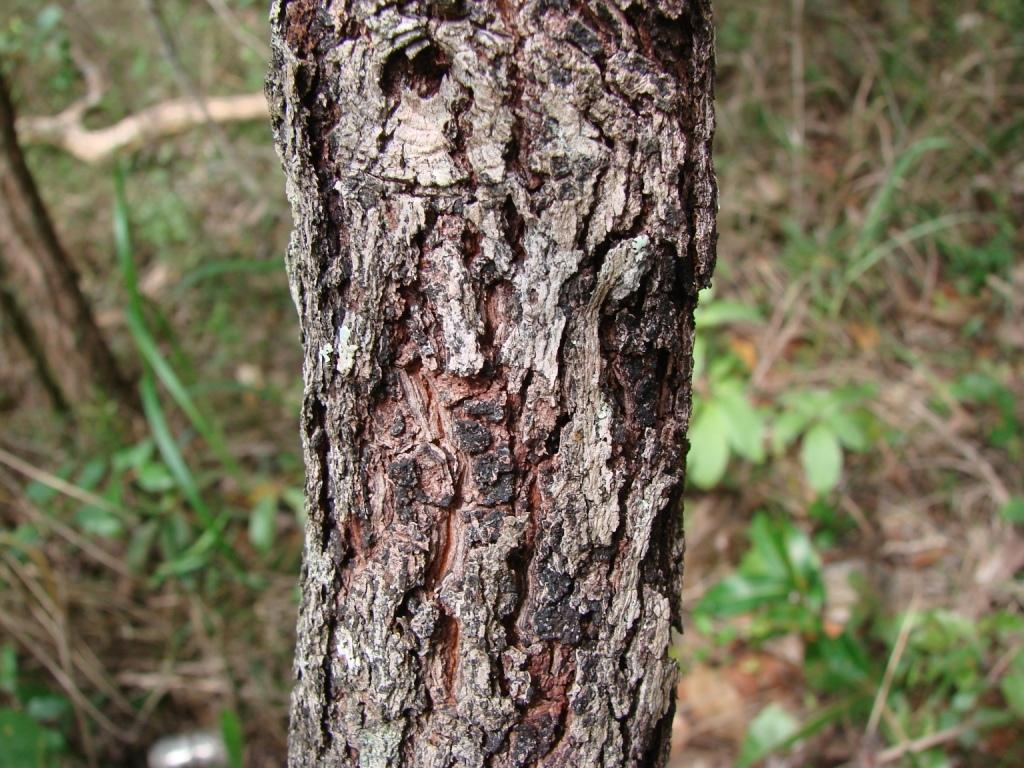What is the main subject in the image? There is a tree trunk in the image. What can be seen in the background of the image? There are plants and wooden objects in the background of the image. How many people are wearing masks in the image? There are no people or masks present in the image. What type of coach can be seen in the image? There is no coach present in the image. 